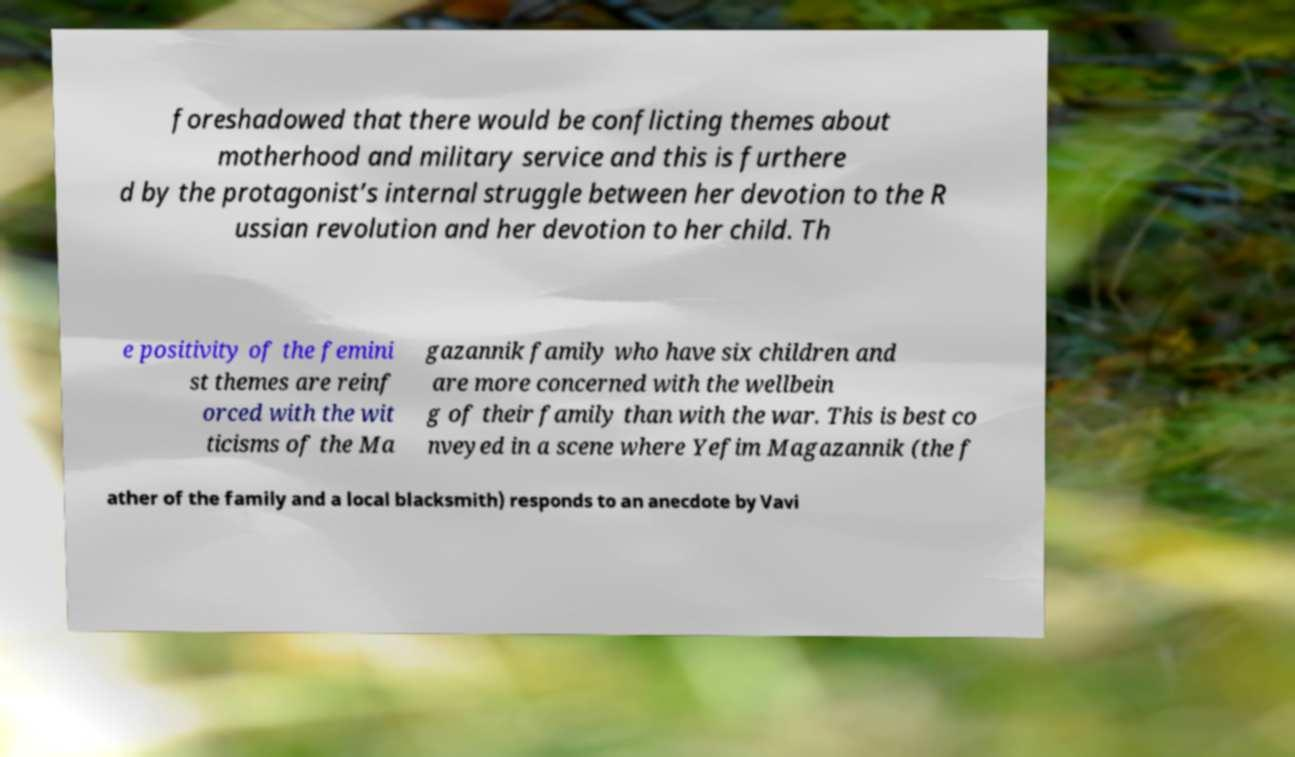Could you extract and type out the text from this image? foreshadowed that there would be conflicting themes about motherhood and military service and this is furthere d by the protagonist’s internal struggle between her devotion to the R ussian revolution and her devotion to her child. Th e positivity of the femini st themes are reinf orced with the wit ticisms of the Ma gazannik family who have six children and are more concerned with the wellbein g of their family than with the war. This is best co nveyed in a scene where Yefim Magazannik (the f ather of the family and a local blacksmith) responds to an anecdote by Vavi 